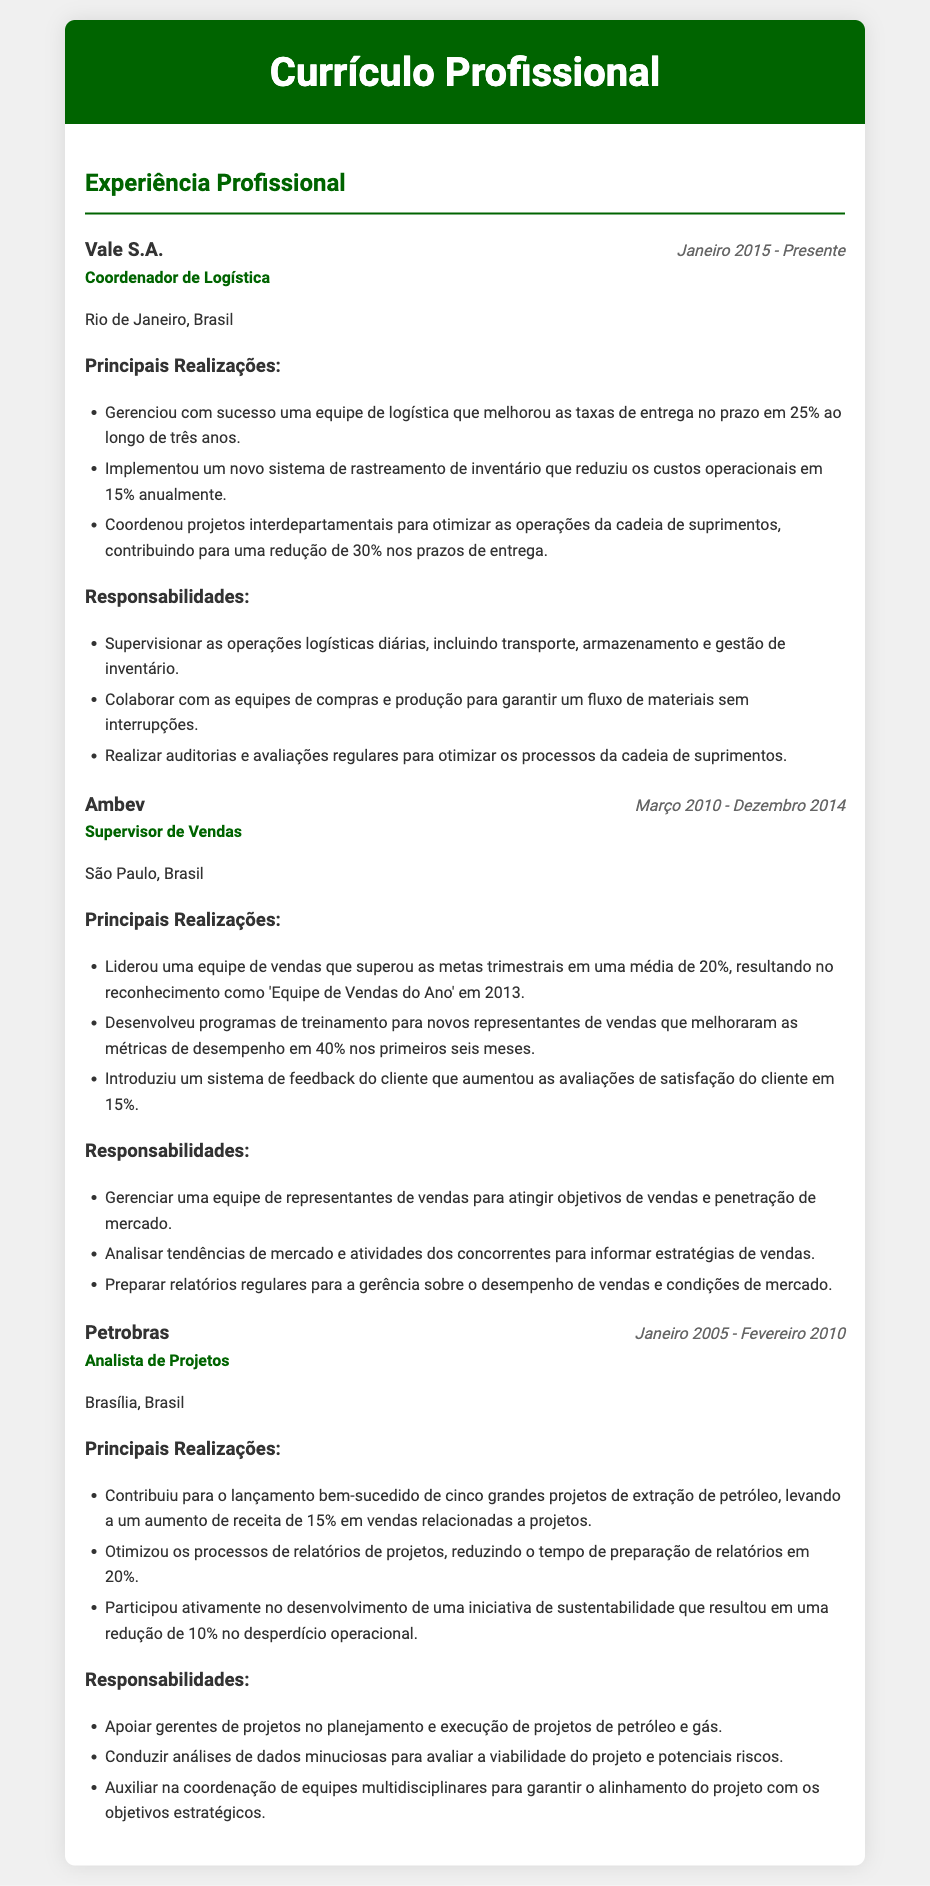what is the current position held? The document states that the current position held is "Coordenador de Logística" at Vale S.A.
Answer: Coordenador de Logística what company did the individual work for in São Paulo? The document indicates that the individual worked for "Ambev" in São Paulo.
Answer: Ambev how long did the individual work at Petrobras? The duration listed for work at Petrobras is from January 2005 to February 2010, which is a total of 5 years.
Answer: 5 anos what was one of the key achievements at Ambev? One of the key achievements listed is leading a sales team that exceeded quarterly targets by an average of 20%.
Answer: superou as metas trimestrais em 20% how much did the new inventory tracking system reduce operational costs by? The document states that the new system reduced operational costs by 15% annually.
Answer: 15% who was recognized as 'Equipe de Vendas do Ano' and in what year? The recognition was given to the sales team at Ambev in 2013.
Answer: 2013 what was one responsibility listed for the role of Coordenador de Logística? One responsibility mentioned is to supervise daily logistics operations, including transport, storage, and inventory management.
Answer: Supervisionar as operações logísticas diárias what is the total number of major projects successfully launched during the tenure at Petrobras? The individual contributed to the launch of five major projects during their time at Petrobras.
Answer: cinco which city was the most recent job located in? The most recent job, as mentioned, is located in Rio de Janeiro.
Answer: Rio de Janeiro 